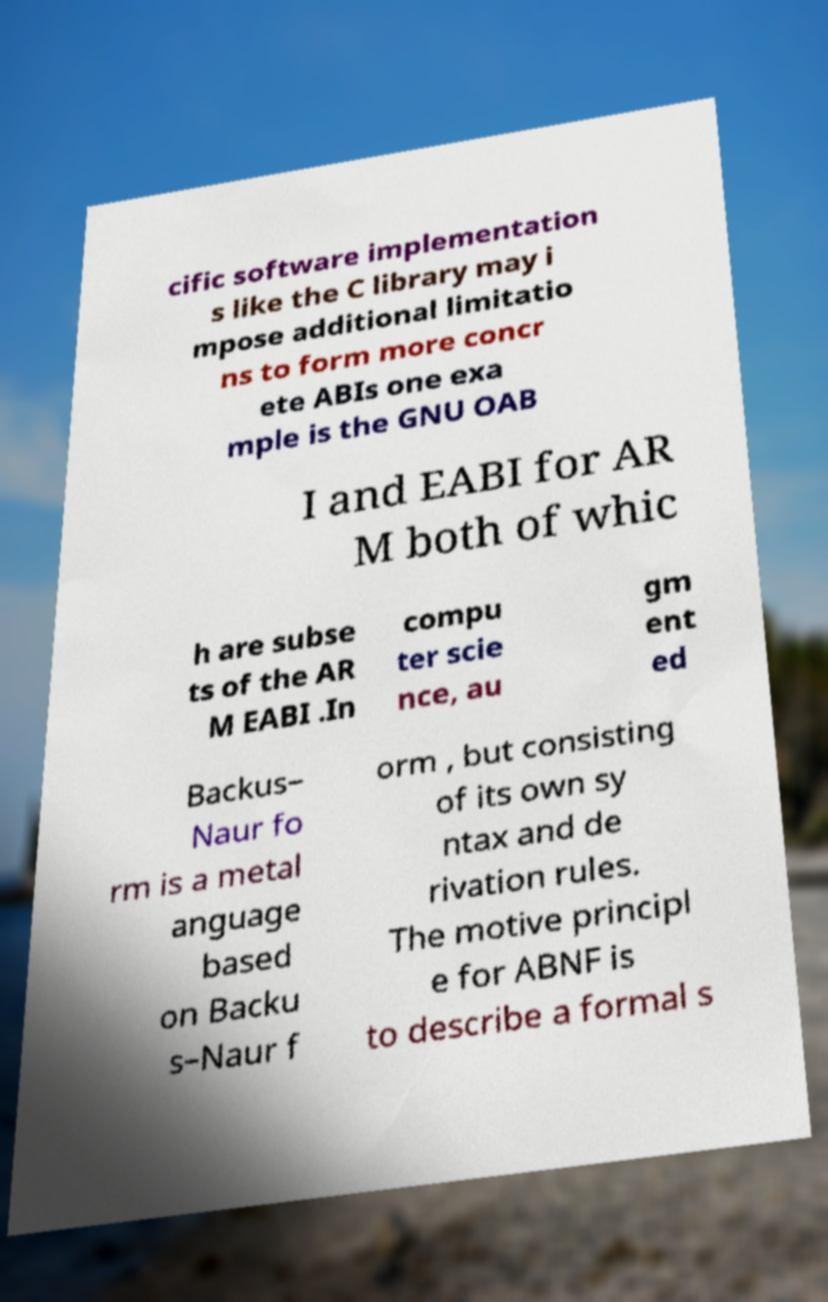There's text embedded in this image that I need extracted. Can you transcribe it verbatim? cific software implementation s like the C library may i mpose additional limitatio ns to form more concr ete ABIs one exa mple is the GNU OAB I and EABI for AR M both of whic h are subse ts of the AR M EABI .In compu ter scie nce, au gm ent ed Backus– Naur fo rm is a metal anguage based on Backu s–Naur f orm , but consisting of its own sy ntax and de rivation rules. The motive principl e for ABNF is to describe a formal s 